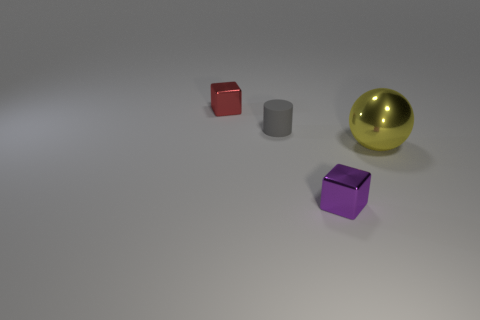Is the number of small gray rubber cylinders in front of the big shiny ball less than the number of tiny red shiny things that are in front of the purple metal object?
Provide a succinct answer. No. Is there anything else that is the same size as the purple cube?
Your response must be concise. Yes. The purple metallic thing has what shape?
Your answer should be very brief. Cube. What is the tiny block in front of the small gray thing made of?
Make the answer very short. Metal. There is a block behind the tiny cube to the right of the tiny block that is to the left of the purple metallic object; how big is it?
Your answer should be compact. Small. Does the block that is behind the large metallic thing have the same material as the object that is to the right of the tiny purple object?
Your response must be concise. Yes. What number of other things are the same color as the big shiny thing?
Offer a very short reply. 0. How many objects are either tiny metallic blocks left of the small purple metallic object or things behind the yellow sphere?
Make the answer very short. 2. There is a cube that is right of the tiny metal block that is behind the tiny purple thing; what is its size?
Your answer should be compact. Small. What size is the purple object?
Offer a terse response. Small. 